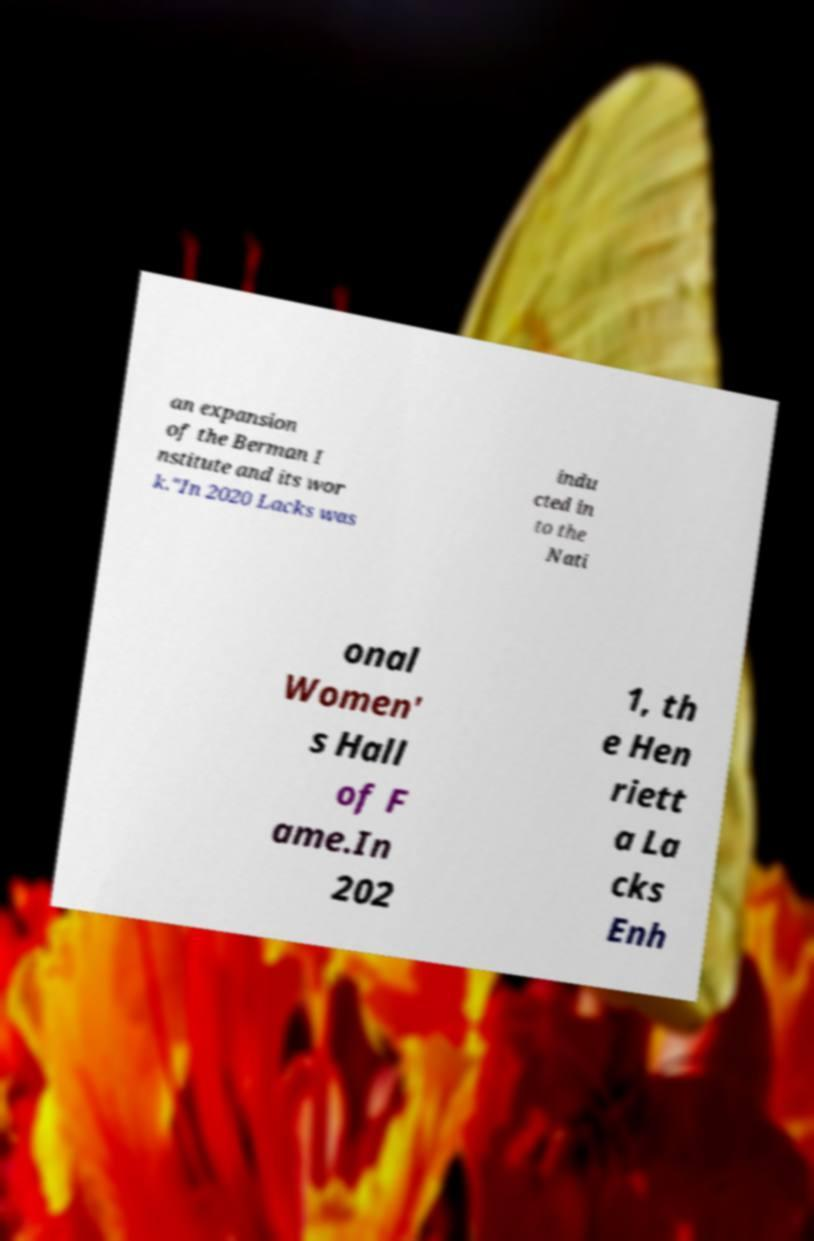Can you read and provide the text displayed in the image?This photo seems to have some interesting text. Can you extract and type it out for me? an expansion of the Berman I nstitute and its wor k."In 2020 Lacks was indu cted in to the Nati onal Women' s Hall of F ame.In 202 1, th e Hen riett a La cks Enh 